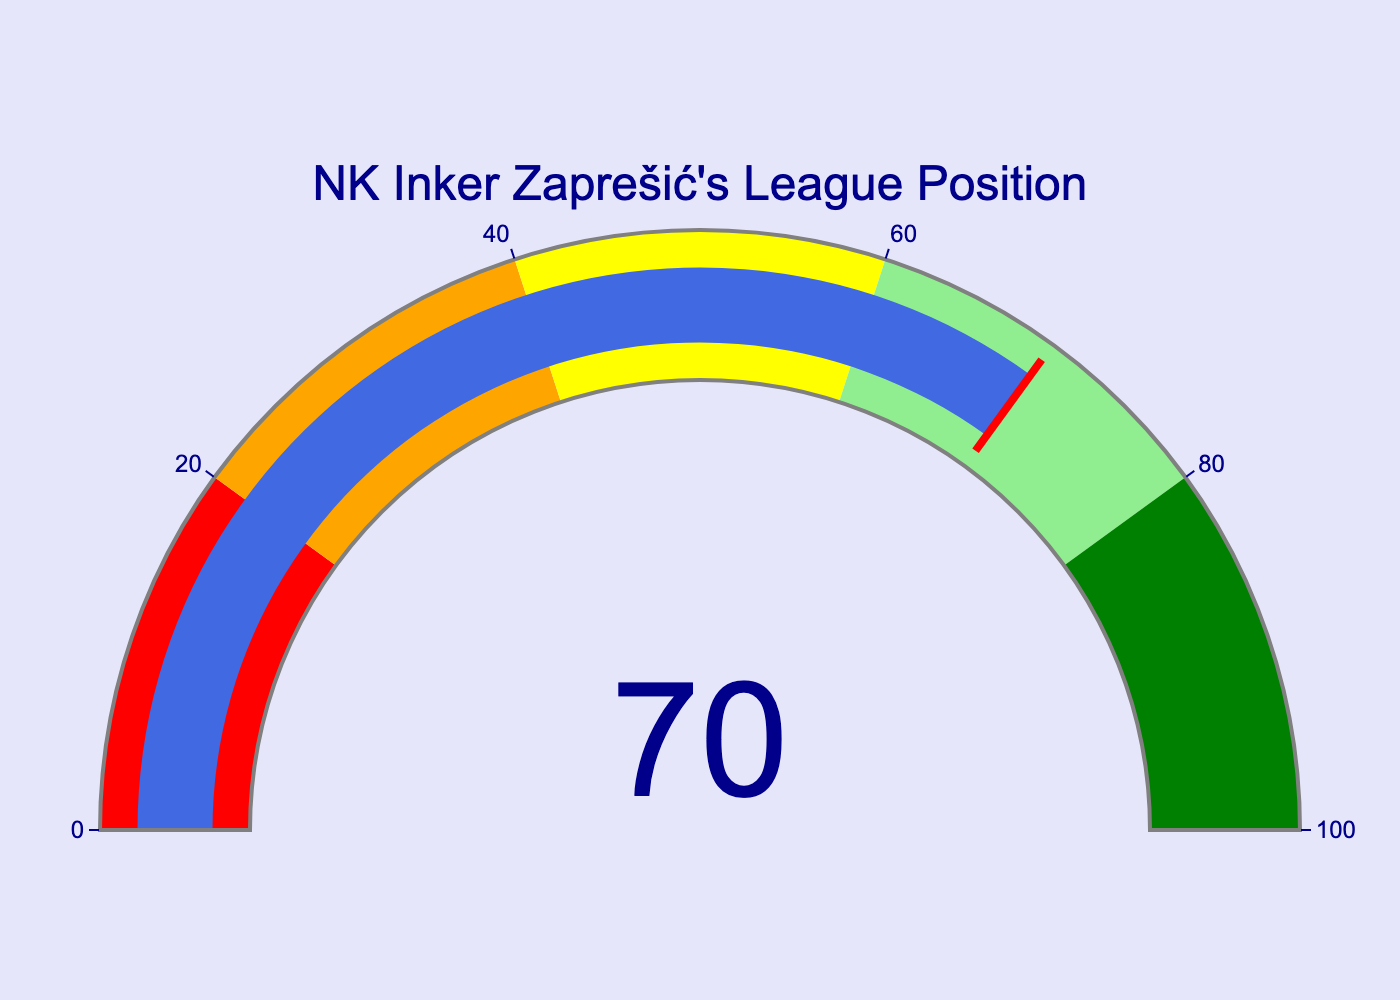What does the gauge represent? The gauge shows a measure related to NK Inker Zaprešić’s league position. The title of the gauge, "NK Inker Zaprešić's League Position," indicates this.
Answer: NK Inker Zaprešić’s league position percentage What is NK Inker Zaprešić's current league position percentage? The number displayed on the gauge shows the current league position percentage of NK Inker Zaprešić.
Answer: 70% Which color segment does NK Inker Zaprešić's league position fall into? The needle points to a value that falls into the light green segment of the gauge.
Answer: Light green What is the range of percentages shown on the gauge? The axis of the gauge indicates that the range of percentages is from 0 to 100.
Answer: 0 to 100 In which part of the gauge is a red threshold line located? There is a red threshold line at the value of NK Inker Zaprešić’s current league position, which is at the 70% mark.
Answer: At 70% What percentage ranges does the light green color cover? The light green color on the gauge covers percentages from 60 to 80.
Answer: 60 to 80 How close is NK Inker Zaprešić's league position percentage to the top of the light green segment? The top of the light green segment is at 80%, and NK Inker Zaprešić's league position is at 70%, so it is 10 percentage points away.
Answer: 10 percentage points away Which color segment indicates the best league position? The best league position is indicated by the green color segment, which covers the last 20% (from 80 to 100).
Answer: Green If NK Inker Zaprešić improved their percentage by 15 points, which color segment would they be in? If their percentage increased by 15 points, their new percentage would be 85%, placing them in the green segment.
Answer: Green How is the visual threshold presented in the gauge chart? The visual threshold is presented as a red line marking the current position value of NK Inker Zaprešić on the gauge.
Answer: Red line at 70% 